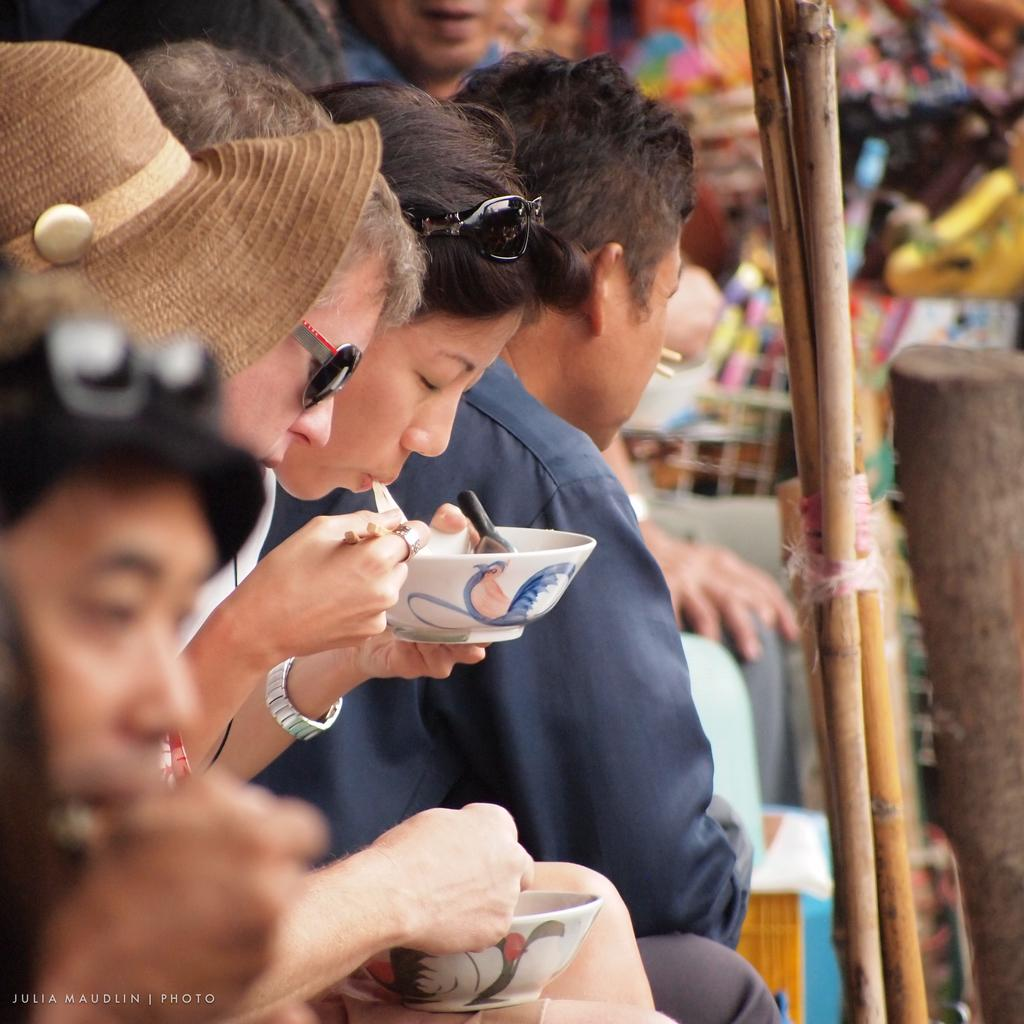What is the main subject of the image? The main subject of the image is a crowd. What are two persons in the crowd doing? Two persons in the crowd are holding a bowl in their hands. What can be seen on the right side of the image? Bamboo sticks are visible on the right side of the image. When was the image taken? The image was taken during the day. What type of wool is being used to make a sweater for mom in the image? There is no wool or sweater for mom present in the image. What is the home address of the person who took the image? The provided facts do not include any information about the person who took the image or their home address. 